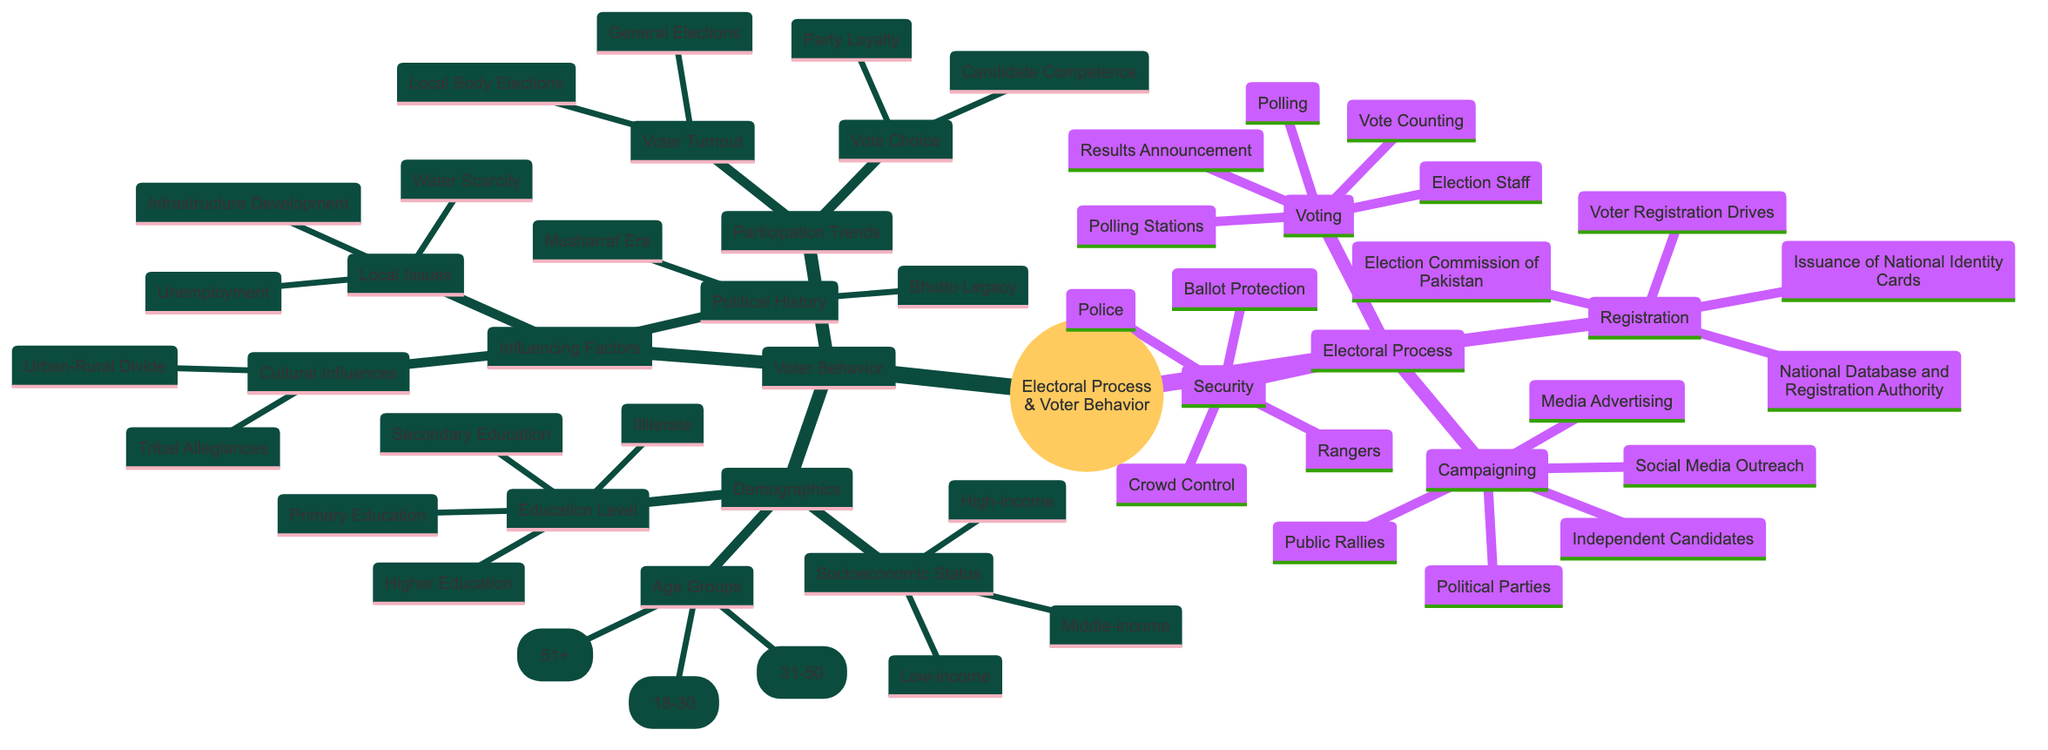What entities are involved in the Registration process? The diagram shows two entities under the Registration process: the Election Commission of Pakistan and the National Database and Registration Authority.
Answer: Election Commission of Pakistan, National Database and Registration Authority How many age groups are identified in the Demographics of Voter Behavior? The diagram lists three distinct age groups related to demographics: Youth (18-30), Middle-aged (31-50), and Elderly (51+). Therefore, there are three age groups mentioned.
Answer: 3 What activities are involved in the Voting process? The diagram specifies three activities that occur during the Voting process: Polling, Vote Counting, and Results Announcement.
Answer: Polling, Vote Counting, Results Announcement Which local issue relates most to infrastructure according to the Influencing Factors? Under Local Issues, the diagram specifically mentions "Infrastructure Development" as an influencing factor, indicating it’s directly related to local concerns.
Answer: Infrastructure Development What is one cultural influence mentioned in the Voter Behavior segment? The diagram indicates two cultural influences: Tribal Allegiances and Urban-Rural Divide. Either could be an answer, but one specific mention is "Tribal Allegiances."
Answer: Tribal Allegiances How do political history factors influence voter behavior? The diagram indicates two specific elements of Political History that influence voter behavior: Bhutto Legacy and Musharraf Era. This illustrates the impact of historical political contexts on current voter decisions.
Answer: Bhutto Legacy, Musharraf Era What are the two types of elections categorized under Voter Turnout? The diagram displays that Voter Turnout includes General Elections and Local Body Elections, indicating these two specific types of electoral events.
Answer: General Elections, Local Body Elections What are the two main activities involved in Security during the electoral process? The diagram outlines two activities related to Security: Crowd Control and Ballot Protection, illustrating the efforts for maintaining safety during elections.
Answer: Crowd Control, Ballot Protection 